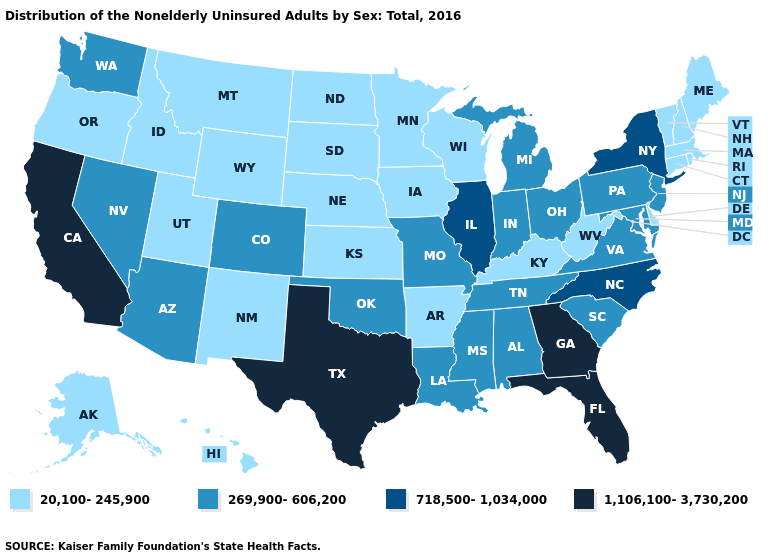Among the states that border Mississippi , does Tennessee have the lowest value?
Keep it brief. No. Does Maine have a lower value than Colorado?
Give a very brief answer. Yes. What is the value of Oklahoma?
Answer briefly. 269,900-606,200. What is the value of Kansas?
Keep it brief. 20,100-245,900. What is the value of Alabama?
Short answer required. 269,900-606,200. What is the value of Georgia?
Quick response, please. 1,106,100-3,730,200. Among the states that border Iowa , does Illinois have the highest value?
Answer briefly. Yes. Name the states that have a value in the range 20,100-245,900?
Give a very brief answer. Alaska, Arkansas, Connecticut, Delaware, Hawaii, Idaho, Iowa, Kansas, Kentucky, Maine, Massachusetts, Minnesota, Montana, Nebraska, New Hampshire, New Mexico, North Dakota, Oregon, Rhode Island, South Dakota, Utah, Vermont, West Virginia, Wisconsin, Wyoming. What is the lowest value in the USA?
Be succinct. 20,100-245,900. Which states have the lowest value in the USA?
Short answer required. Alaska, Arkansas, Connecticut, Delaware, Hawaii, Idaho, Iowa, Kansas, Kentucky, Maine, Massachusetts, Minnesota, Montana, Nebraska, New Hampshire, New Mexico, North Dakota, Oregon, Rhode Island, South Dakota, Utah, Vermont, West Virginia, Wisconsin, Wyoming. Does Hawaii have the highest value in the USA?
Concise answer only. No. Among the states that border Oklahoma , which have the lowest value?
Answer briefly. Arkansas, Kansas, New Mexico. Which states have the lowest value in the West?
Short answer required. Alaska, Hawaii, Idaho, Montana, New Mexico, Oregon, Utah, Wyoming. Among the states that border New Hampshire , which have the lowest value?
Be succinct. Maine, Massachusetts, Vermont. 